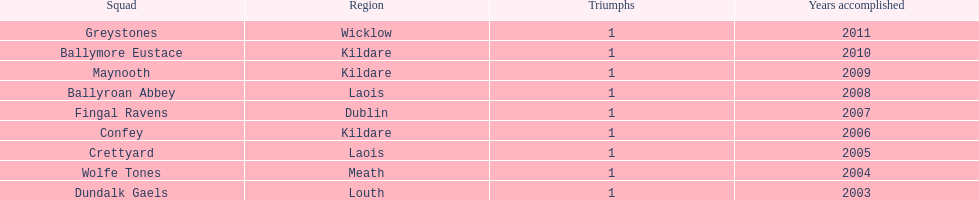Ballymore eustace is part of the same county as which team that succeeded in 2009? Maynooth. 